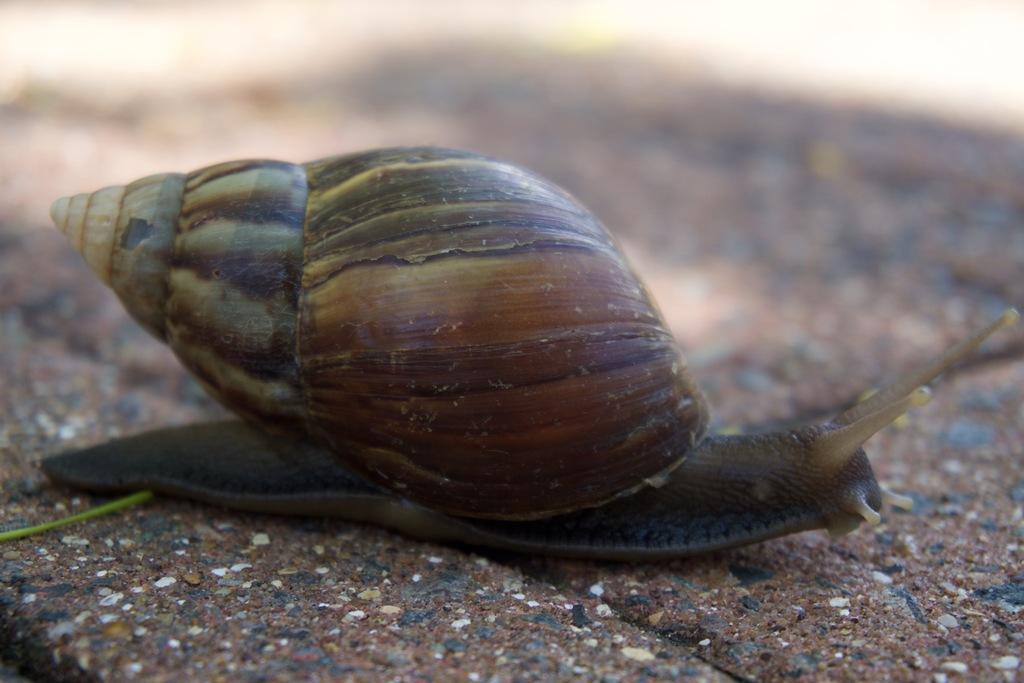Please provide a concise description of this image. In the picture we can see a snail on the path and on the top of it we can see a shell. 